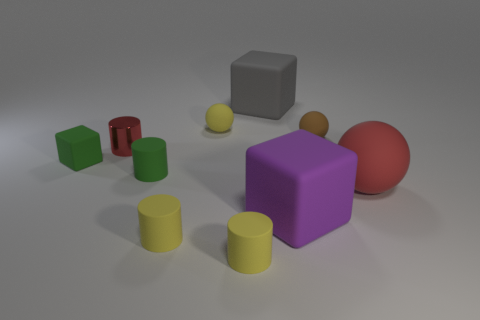What is the material of the object that is the same color as the small metallic cylinder?
Your answer should be compact. Rubber. Do the shiny cylinder and the tiny cube have the same color?
Your answer should be compact. No. There is a brown matte ball; are there any shiny objects behind it?
Your response must be concise. No. There is a small green rubber object in front of the small green matte object that is behind the tiny green cylinder; what is its shape?
Provide a succinct answer. Cylinder. Are there fewer large matte blocks right of the tiny red metallic object than gray matte cubes in front of the small brown thing?
Your answer should be compact. No. There is a tiny matte thing that is the same shape as the big purple matte object; what is its color?
Give a very brief answer. Green. How many things are in front of the brown ball and on the right side of the gray matte block?
Offer a terse response. 2. Is the number of tiny metallic cylinders in front of the big red ball greater than the number of rubber balls that are left of the tiny red object?
Offer a terse response. No. How big is the gray cube?
Offer a terse response. Large. Are there any other purple things of the same shape as the purple rubber object?
Your answer should be very brief. No. 